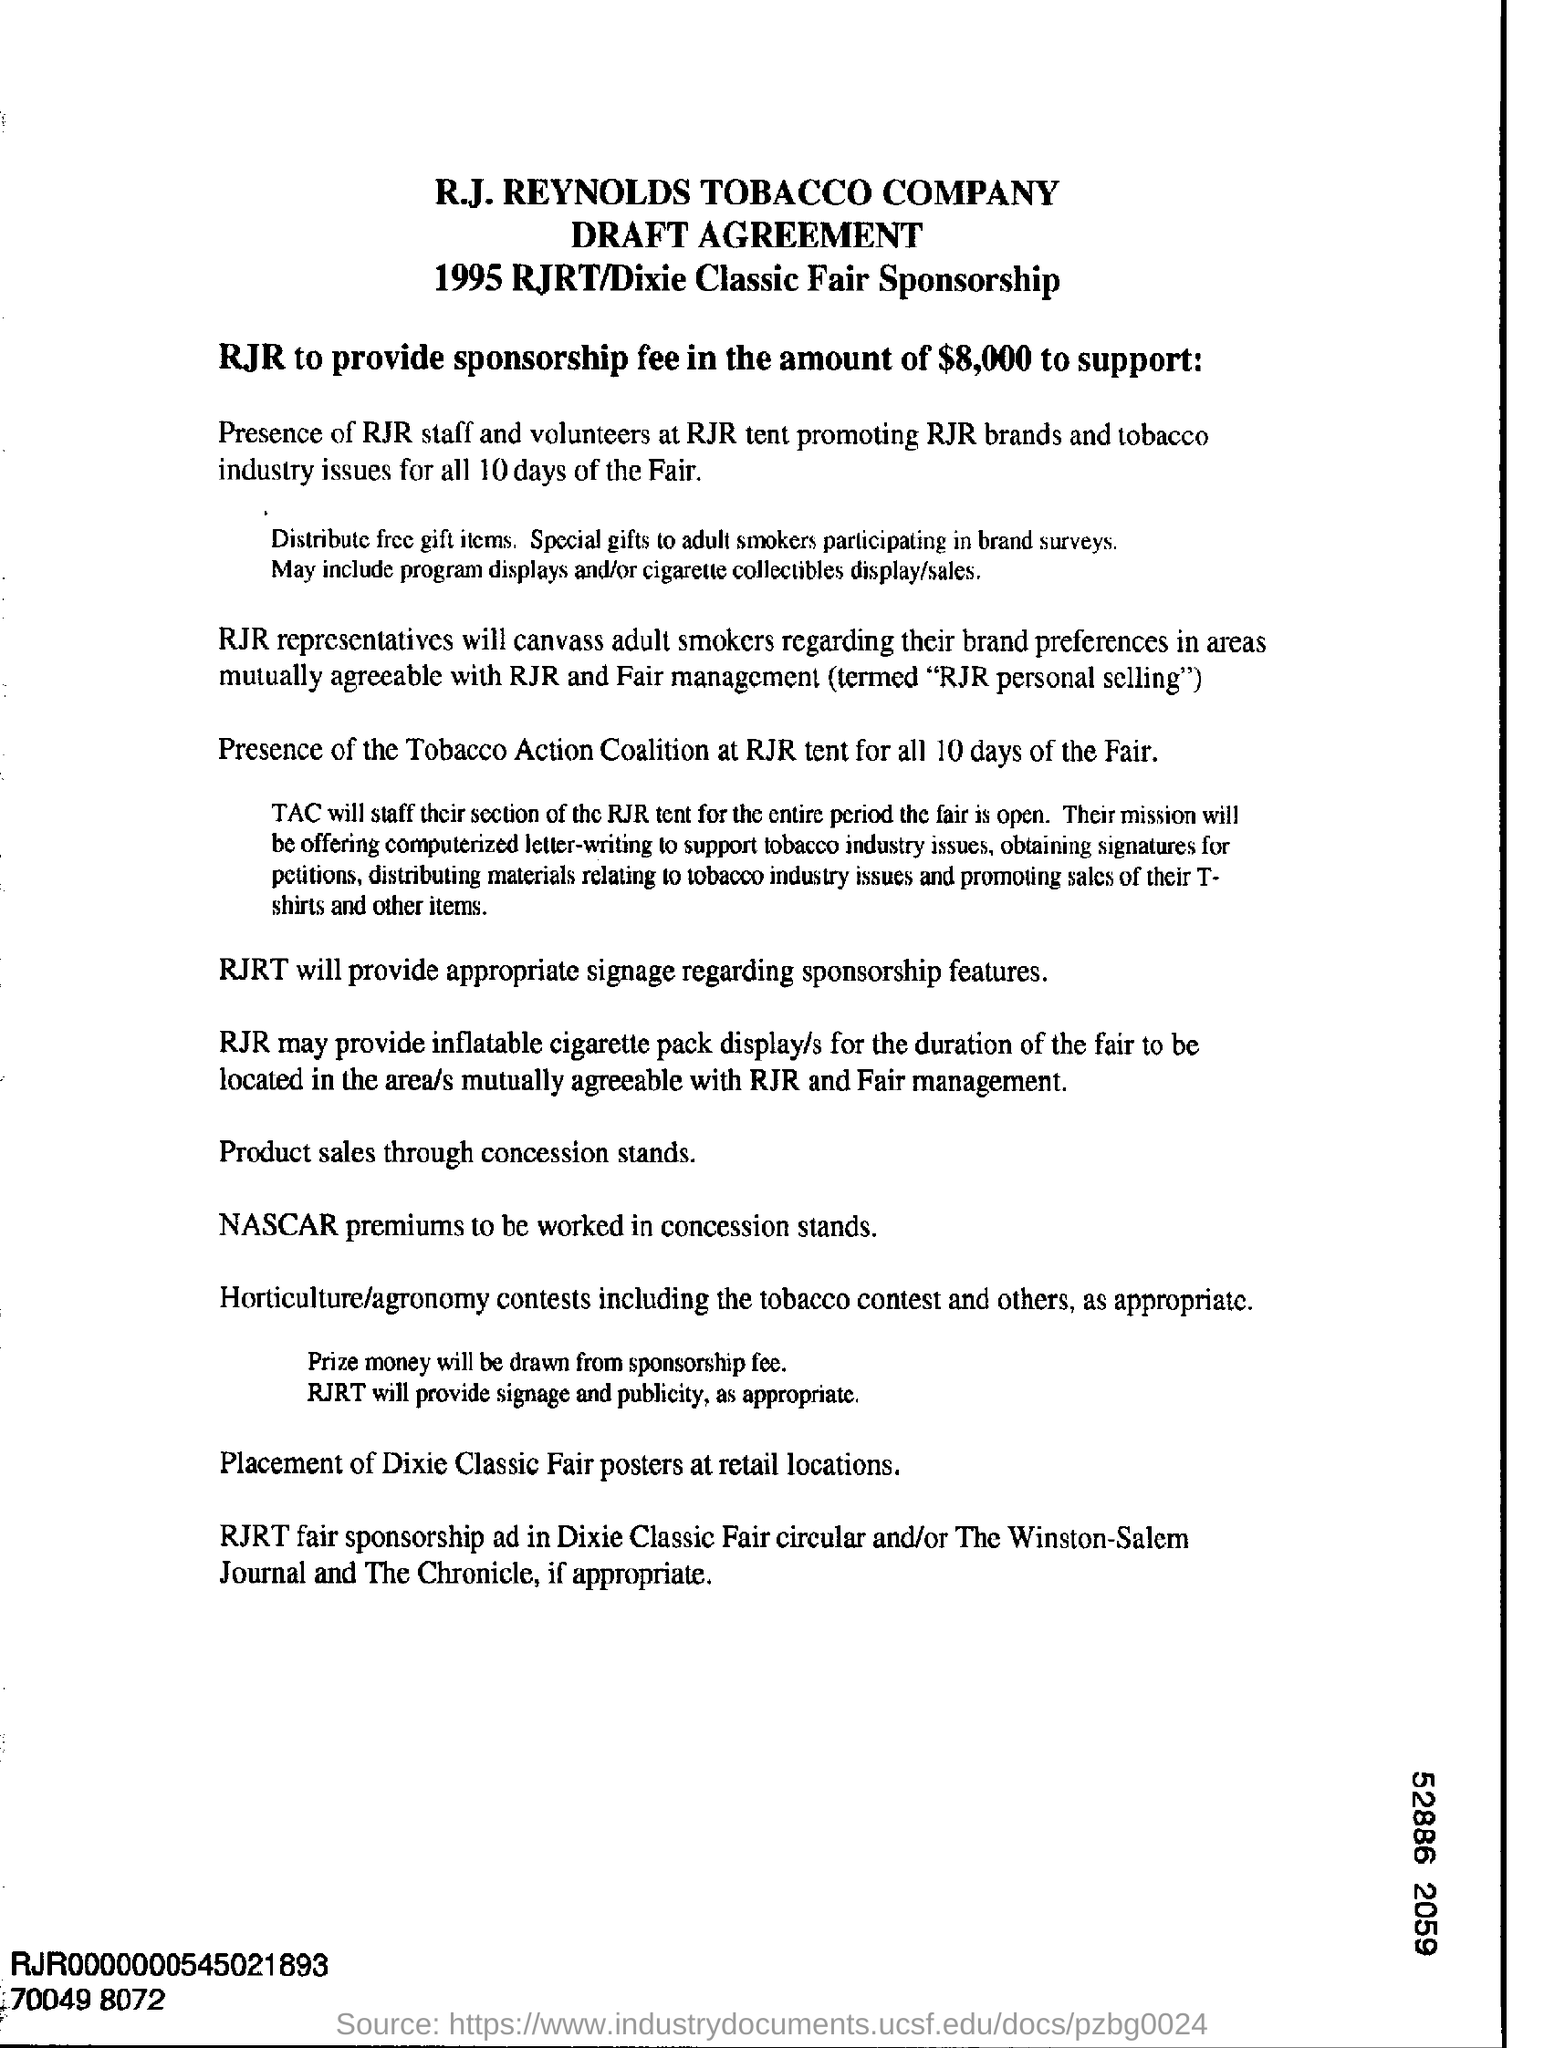How much sponsorship fee will RJR provide?
Your answer should be compact. $8,000. How many days is the fair?
Your answer should be very brief. 10 days. Who will be present at RJR tent for all 10 days of the Fair?
Ensure brevity in your answer.  The tobacco action coalition. 